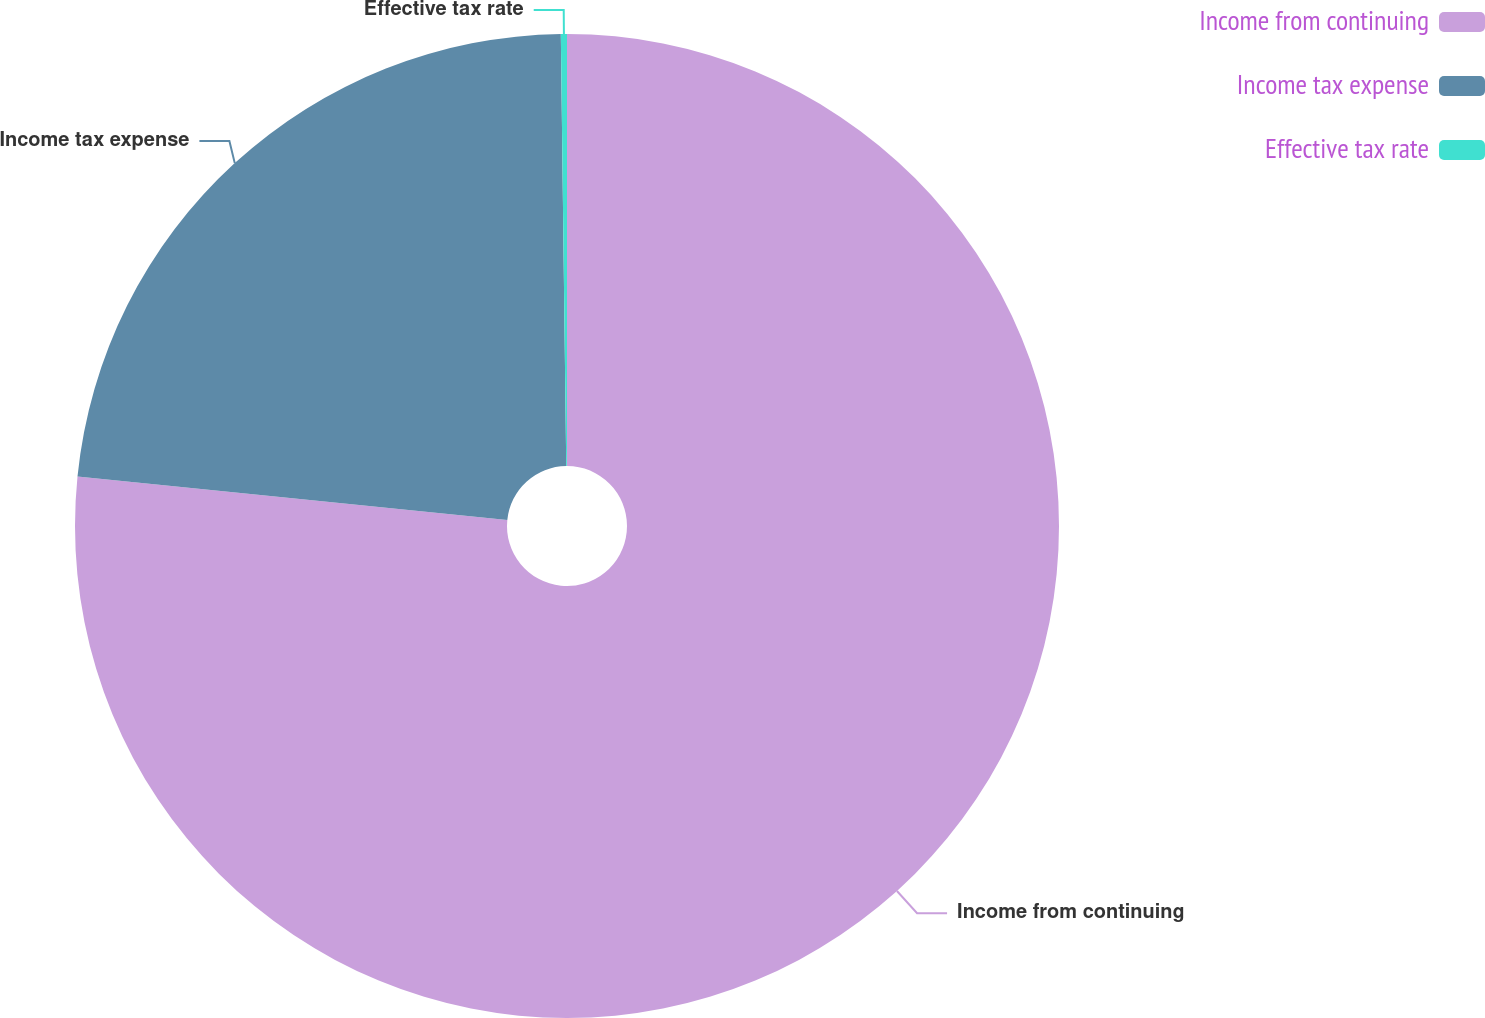<chart> <loc_0><loc_0><loc_500><loc_500><pie_chart><fcel>Income from continuing<fcel>Income tax expense<fcel>Effective tax rate<nl><fcel>76.61%<fcel>23.2%<fcel>0.2%<nl></chart> 